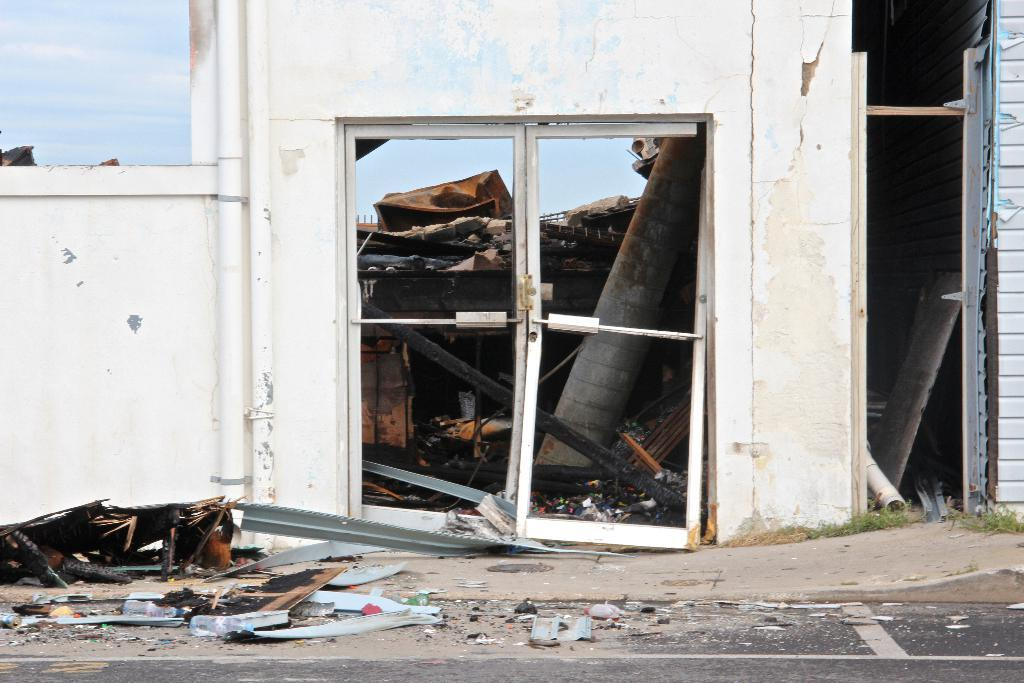What is the main subject of the image? The main subject of the image is a collapsed building. What can be seen on the wall of the building? There are pipes on the wall of the building. What is visible behind the wall in the image? The sky is visible behind the wall in the image. What position does the pencil hold in the image? There is no pencil present in the image. 